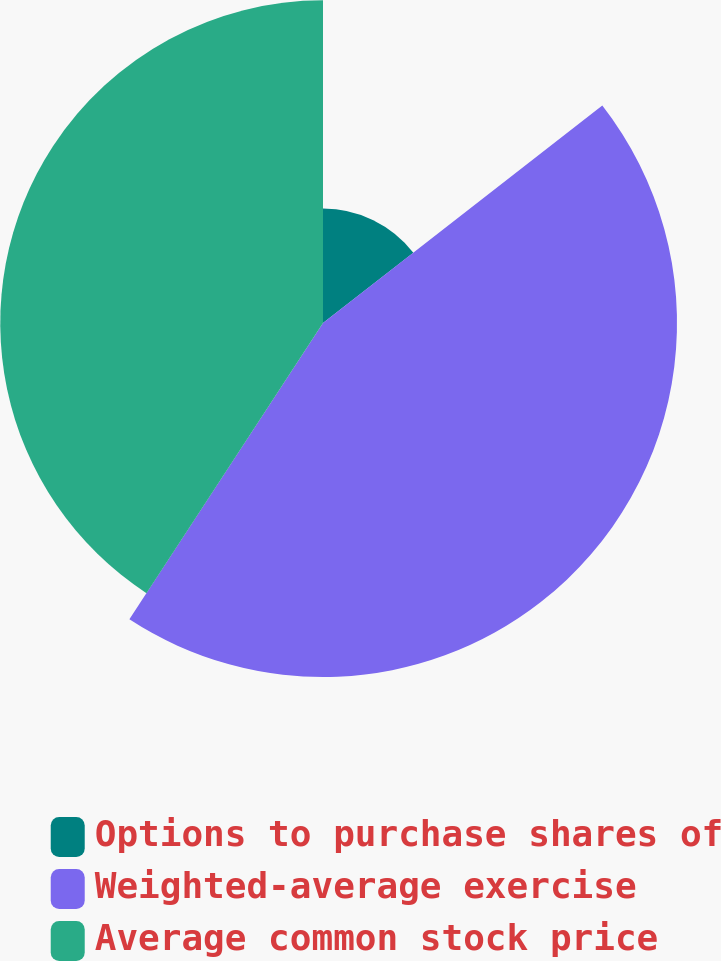Convert chart. <chart><loc_0><loc_0><loc_500><loc_500><pie_chart><fcel>Options to purchase shares of<fcel>Weighted-average exercise<fcel>Average common stock price<nl><fcel>14.47%<fcel>44.74%<fcel>40.79%<nl></chart> 